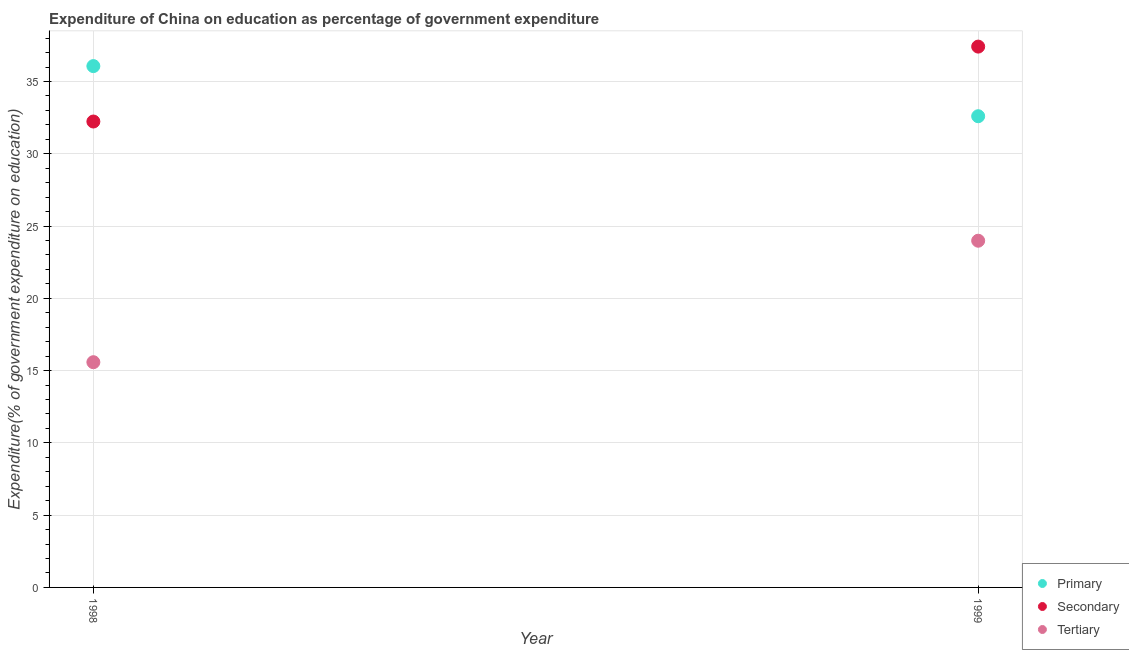How many different coloured dotlines are there?
Your answer should be compact. 3. Is the number of dotlines equal to the number of legend labels?
Your answer should be compact. Yes. What is the expenditure on secondary education in 1999?
Ensure brevity in your answer.  37.41. Across all years, what is the maximum expenditure on tertiary education?
Make the answer very short. 23.98. Across all years, what is the minimum expenditure on primary education?
Offer a very short reply. 32.6. In which year was the expenditure on tertiary education maximum?
Keep it short and to the point. 1999. What is the total expenditure on primary education in the graph?
Your answer should be compact. 68.66. What is the difference between the expenditure on primary education in 1998 and that in 1999?
Offer a terse response. 3.47. What is the difference between the expenditure on tertiary education in 1999 and the expenditure on primary education in 1998?
Offer a very short reply. -12.08. What is the average expenditure on secondary education per year?
Offer a very short reply. 34.82. In the year 1998, what is the difference between the expenditure on tertiary education and expenditure on primary education?
Offer a terse response. -20.48. What is the ratio of the expenditure on primary education in 1998 to that in 1999?
Provide a succinct answer. 1.11. Is the expenditure on secondary education in 1998 less than that in 1999?
Provide a succinct answer. Yes. In how many years, is the expenditure on tertiary education greater than the average expenditure on tertiary education taken over all years?
Provide a short and direct response. 1. Does the expenditure on secondary education monotonically increase over the years?
Make the answer very short. Yes. Is the expenditure on primary education strictly greater than the expenditure on secondary education over the years?
Make the answer very short. No. Is the expenditure on primary education strictly less than the expenditure on tertiary education over the years?
Make the answer very short. No. How many dotlines are there?
Make the answer very short. 3. How many years are there in the graph?
Offer a terse response. 2. Does the graph contain any zero values?
Offer a terse response. No. Where does the legend appear in the graph?
Make the answer very short. Bottom right. How many legend labels are there?
Ensure brevity in your answer.  3. How are the legend labels stacked?
Provide a succinct answer. Vertical. What is the title of the graph?
Your answer should be compact. Expenditure of China on education as percentage of government expenditure. What is the label or title of the Y-axis?
Make the answer very short. Expenditure(% of government expenditure on education). What is the Expenditure(% of government expenditure on education) in Primary in 1998?
Your answer should be very brief. 36.06. What is the Expenditure(% of government expenditure on education) in Secondary in 1998?
Give a very brief answer. 32.23. What is the Expenditure(% of government expenditure on education) in Tertiary in 1998?
Provide a short and direct response. 15.58. What is the Expenditure(% of government expenditure on education) in Primary in 1999?
Give a very brief answer. 32.6. What is the Expenditure(% of government expenditure on education) of Secondary in 1999?
Offer a terse response. 37.41. What is the Expenditure(% of government expenditure on education) of Tertiary in 1999?
Offer a terse response. 23.98. Across all years, what is the maximum Expenditure(% of government expenditure on education) of Primary?
Ensure brevity in your answer.  36.06. Across all years, what is the maximum Expenditure(% of government expenditure on education) in Secondary?
Your answer should be compact. 37.41. Across all years, what is the maximum Expenditure(% of government expenditure on education) of Tertiary?
Your answer should be compact. 23.98. Across all years, what is the minimum Expenditure(% of government expenditure on education) of Primary?
Make the answer very short. 32.6. Across all years, what is the minimum Expenditure(% of government expenditure on education) in Secondary?
Your answer should be compact. 32.23. Across all years, what is the minimum Expenditure(% of government expenditure on education) of Tertiary?
Offer a terse response. 15.58. What is the total Expenditure(% of government expenditure on education) of Primary in the graph?
Offer a terse response. 68.66. What is the total Expenditure(% of government expenditure on education) of Secondary in the graph?
Offer a terse response. 69.64. What is the total Expenditure(% of government expenditure on education) of Tertiary in the graph?
Keep it short and to the point. 39.56. What is the difference between the Expenditure(% of government expenditure on education) in Primary in 1998 and that in 1999?
Your answer should be compact. 3.47. What is the difference between the Expenditure(% of government expenditure on education) of Secondary in 1998 and that in 1999?
Give a very brief answer. -5.18. What is the difference between the Expenditure(% of government expenditure on education) in Tertiary in 1998 and that in 1999?
Provide a short and direct response. -8.4. What is the difference between the Expenditure(% of government expenditure on education) in Primary in 1998 and the Expenditure(% of government expenditure on education) in Secondary in 1999?
Keep it short and to the point. -1.35. What is the difference between the Expenditure(% of government expenditure on education) of Primary in 1998 and the Expenditure(% of government expenditure on education) of Tertiary in 1999?
Make the answer very short. 12.08. What is the difference between the Expenditure(% of government expenditure on education) in Secondary in 1998 and the Expenditure(% of government expenditure on education) in Tertiary in 1999?
Make the answer very short. 8.25. What is the average Expenditure(% of government expenditure on education) in Primary per year?
Keep it short and to the point. 34.33. What is the average Expenditure(% of government expenditure on education) of Secondary per year?
Your answer should be very brief. 34.82. What is the average Expenditure(% of government expenditure on education) in Tertiary per year?
Your answer should be very brief. 19.78. In the year 1998, what is the difference between the Expenditure(% of government expenditure on education) of Primary and Expenditure(% of government expenditure on education) of Secondary?
Make the answer very short. 3.83. In the year 1998, what is the difference between the Expenditure(% of government expenditure on education) in Primary and Expenditure(% of government expenditure on education) in Tertiary?
Your response must be concise. 20.48. In the year 1998, what is the difference between the Expenditure(% of government expenditure on education) in Secondary and Expenditure(% of government expenditure on education) in Tertiary?
Your answer should be compact. 16.65. In the year 1999, what is the difference between the Expenditure(% of government expenditure on education) in Primary and Expenditure(% of government expenditure on education) in Secondary?
Your answer should be compact. -4.82. In the year 1999, what is the difference between the Expenditure(% of government expenditure on education) of Primary and Expenditure(% of government expenditure on education) of Tertiary?
Make the answer very short. 8.61. In the year 1999, what is the difference between the Expenditure(% of government expenditure on education) in Secondary and Expenditure(% of government expenditure on education) in Tertiary?
Your answer should be compact. 13.43. What is the ratio of the Expenditure(% of government expenditure on education) in Primary in 1998 to that in 1999?
Provide a short and direct response. 1.11. What is the ratio of the Expenditure(% of government expenditure on education) of Secondary in 1998 to that in 1999?
Your answer should be very brief. 0.86. What is the ratio of the Expenditure(% of government expenditure on education) in Tertiary in 1998 to that in 1999?
Your answer should be compact. 0.65. What is the difference between the highest and the second highest Expenditure(% of government expenditure on education) of Primary?
Offer a terse response. 3.47. What is the difference between the highest and the second highest Expenditure(% of government expenditure on education) in Secondary?
Give a very brief answer. 5.18. What is the difference between the highest and the second highest Expenditure(% of government expenditure on education) of Tertiary?
Your answer should be very brief. 8.4. What is the difference between the highest and the lowest Expenditure(% of government expenditure on education) of Primary?
Your answer should be compact. 3.47. What is the difference between the highest and the lowest Expenditure(% of government expenditure on education) in Secondary?
Give a very brief answer. 5.18. What is the difference between the highest and the lowest Expenditure(% of government expenditure on education) of Tertiary?
Make the answer very short. 8.4. 